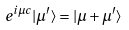<formula> <loc_0><loc_0><loc_500><loc_500>e ^ { i \mu c } | \mu ^ { \prime } \rangle = | \mu + \mu ^ { \prime } \rangle</formula> 